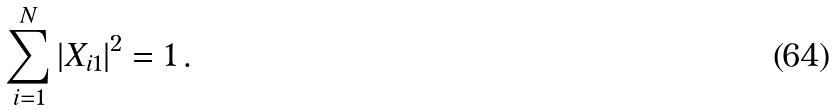<formula> <loc_0><loc_0><loc_500><loc_500>\sum _ { i = 1 } ^ { N } | X _ { i 1 } | ^ { 2 } = 1 \, .</formula> 